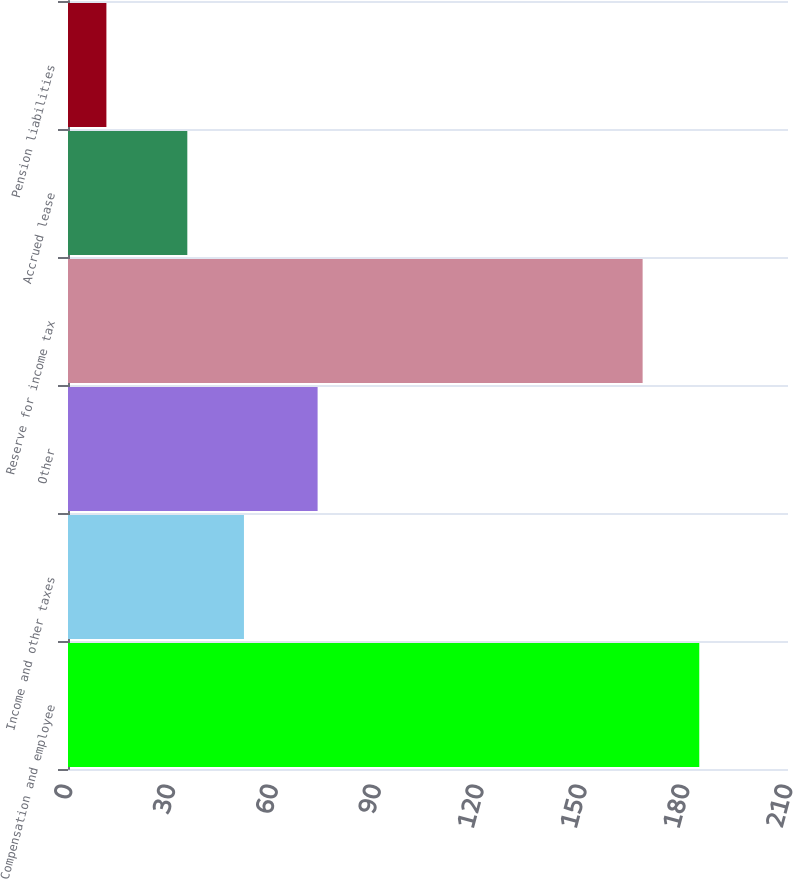<chart> <loc_0><loc_0><loc_500><loc_500><bar_chart><fcel>Compensation and employee<fcel>Income and other taxes<fcel>Other<fcel>Reserve for income tax<fcel>Accrued lease<fcel>Pension liabilities<nl><fcel>184.12<fcel>51.32<fcel>72.8<fcel>167.6<fcel>34.8<fcel>11.2<nl></chart> 